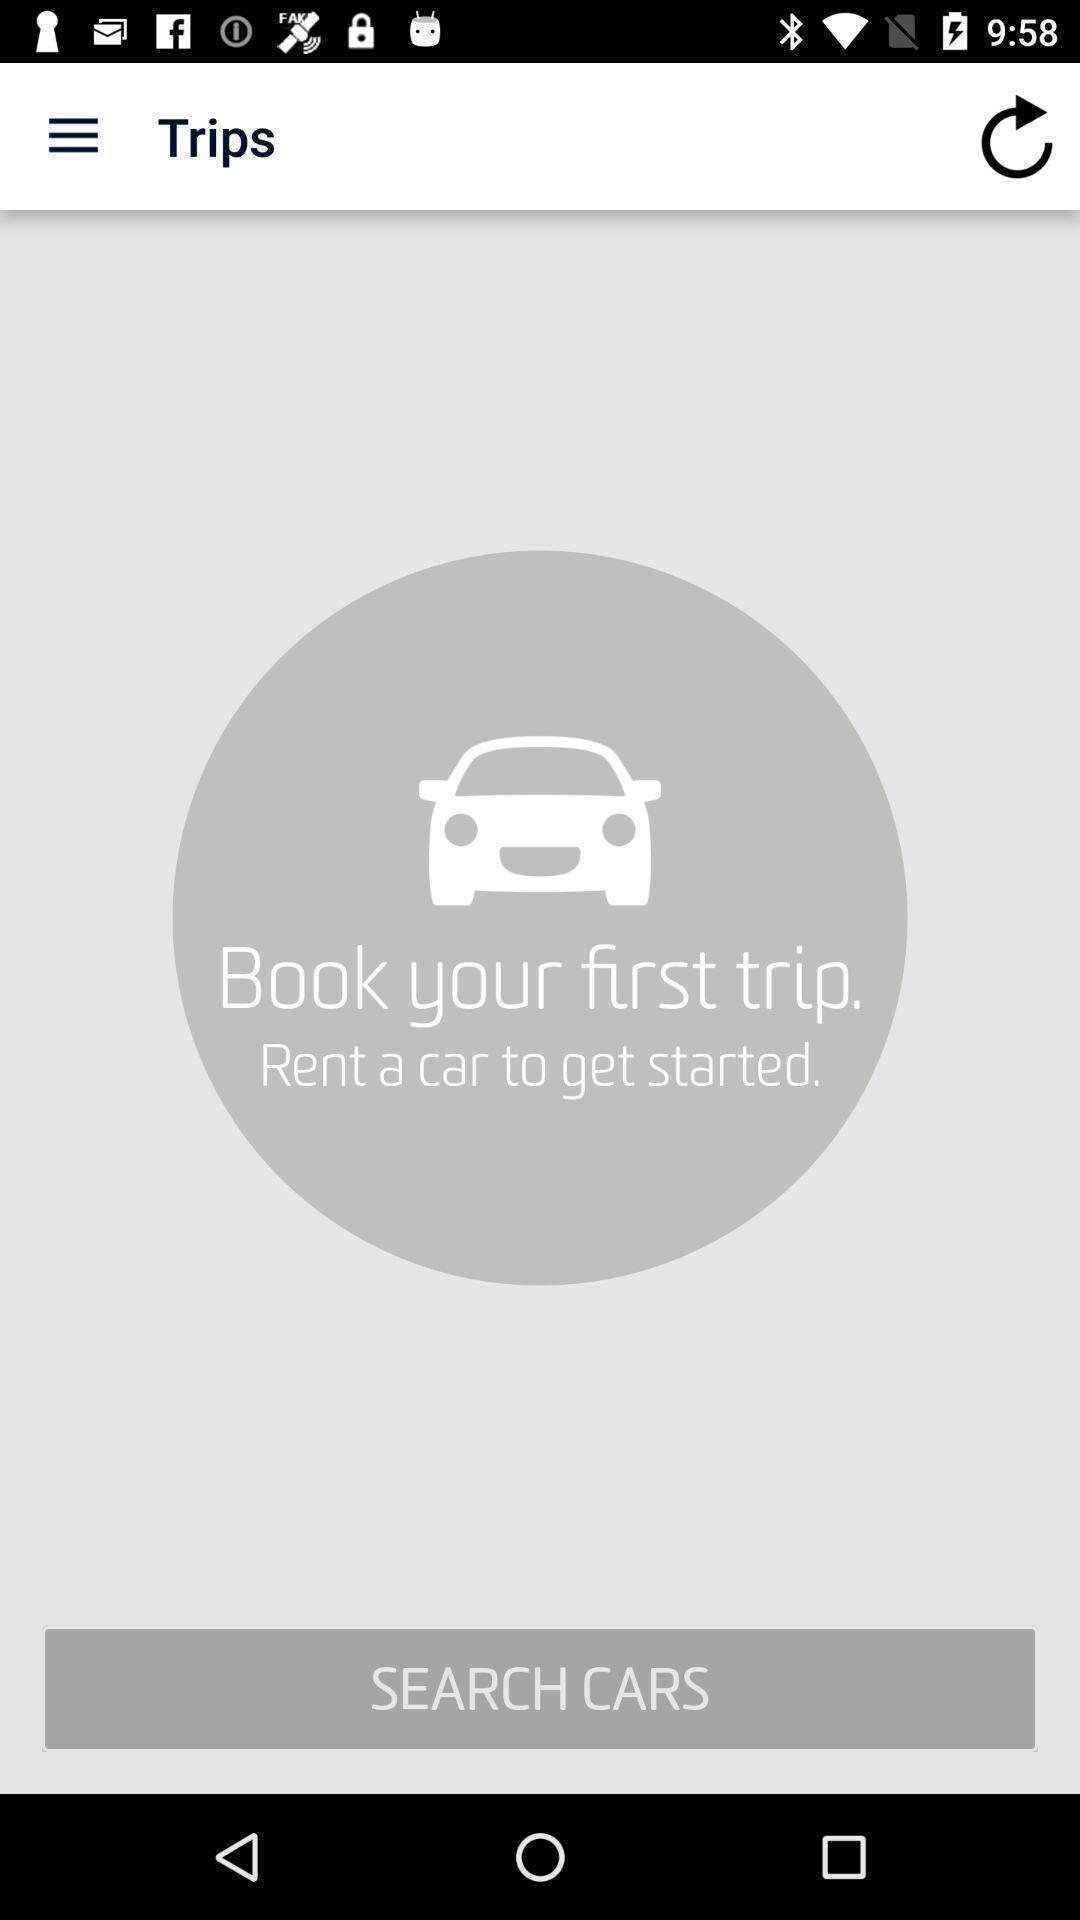Describe the key features of this screenshot. Screen displaying booking information in an e-hailing application. 